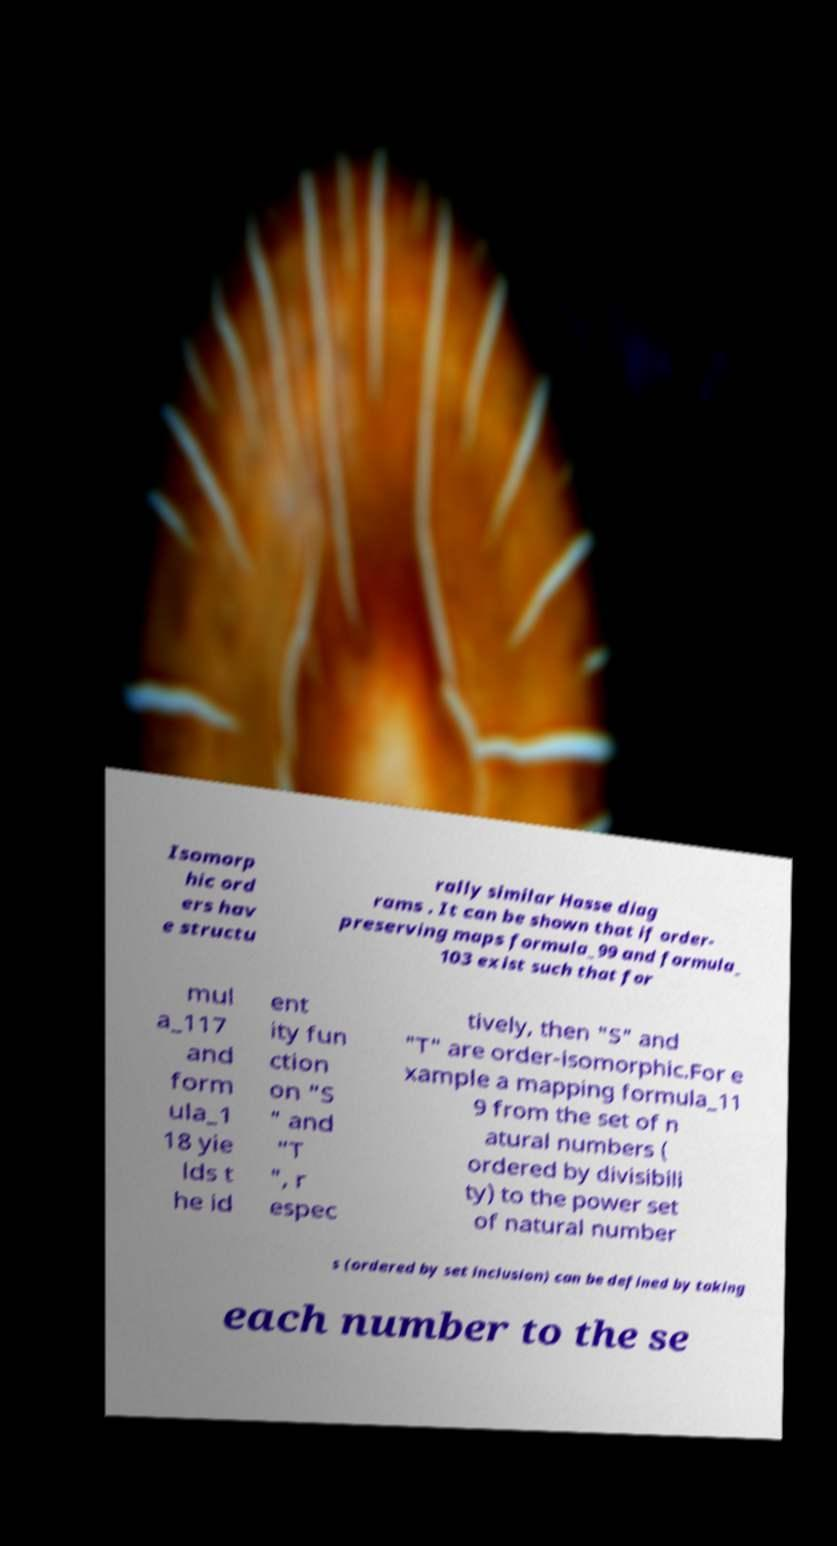Could you assist in decoding the text presented in this image and type it out clearly? Isomorp hic ord ers hav e structu rally similar Hasse diag rams . It can be shown that if order- preserving maps formula_99 and formula_ 103 exist such that for mul a_117 and form ula_1 18 yie lds t he id ent ity fun ction on "S " and "T ", r espec tively, then "S" and "T" are order-isomorphic.For e xample a mapping formula_11 9 from the set of n atural numbers ( ordered by divisibili ty) to the power set of natural number s (ordered by set inclusion) can be defined by taking each number to the se 